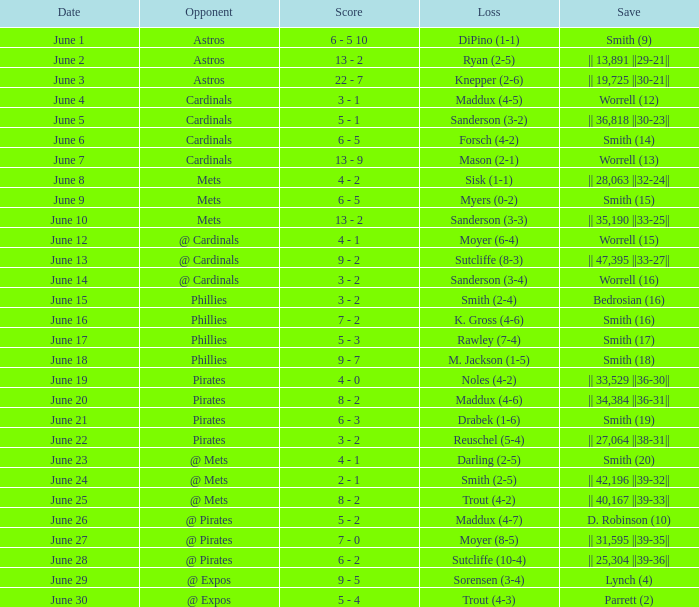Can you parse all the data within this table? {'header': ['Date', 'Opponent', 'Score', 'Loss', 'Save'], 'rows': [['June 1', 'Astros', '6 - 5 10', 'DiPino (1-1)', 'Smith (9)'], ['June 2', 'Astros', '13 - 2', 'Ryan (2-5)', '|| 13,891 ||29-21||'], ['June 3', 'Astros', '22 - 7', 'Knepper (2-6)', '|| 19,725 ||30-21||'], ['June 4', 'Cardinals', '3 - 1', 'Maddux (4-5)', 'Worrell (12)'], ['June 5', 'Cardinals', '5 - 1', 'Sanderson (3-2)', '|| 36,818 ||30-23||'], ['June 6', 'Cardinals', '6 - 5', 'Forsch (4-2)', 'Smith (14)'], ['June 7', 'Cardinals', '13 - 9', 'Mason (2-1)', 'Worrell (13)'], ['June 8', 'Mets', '4 - 2', 'Sisk (1-1)', '|| 28,063 ||32-24||'], ['June 9', 'Mets', '6 - 5', 'Myers (0-2)', 'Smith (15)'], ['June 10', 'Mets', '13 - 2', 'Sanderson (3-3)', '|| 35,190 ||33-25||'], ['June 12', '@ Cardinals', '4 - 1', 'Moyer (6-4)', 'Worrell (15)'], ['June 13', '@ Cardinals', '9 - 2', 'Sutcliffe (8-3)', '|| 47,395 ||33-27||'], ['June 14', '@ Cardinals', '3 - 2', 'Sanderson (3-4)', 'Worrell (16)'], ['June 15', 'Phillies', '3 - 2', 'Smith (2-4)', 'Bedrosian (16)'], ['June 16', 'Phillies', '7 - 2', 'K. Gross (4-6)', 'Smith (16)'], ['June 17', 'Phillies', '5 - 3', 'Rawley (7-4)', 'Smith (17)'], ['June 18', 'Phillies', '9 - 7', 'M. Jackson (1-5)', 'Smith (18)'], ['June 19', 'Pirates', '4 - 0', 'Noles (4-2)', '|| 33,529 ||36-30||'], ['June 20', 'Pirates', '8 - 2', 'Maddux (4-6)', '|| 34,384 ||36-31||'], ['June 21', 'Pirates', '6 - 3', 'Drabek (1-6)', 'Smith (19)'], ['June 22', 'Pirates', '3 - 2', 'Reuschel (5-4)', '|| 27,064 ||38-31||'], ['June 23', '@ Mets', '4 - 1', 'Darling (2-5)', 'Smith (20)'], ['June 24', '@ Mets', '2 - 1', 'Smith (2-5)', '|| 42,196 ||39-32||'], ['June 25', '@ Mets', '8 - 2', 'Trout (4-2)', '|| 40,167 ||39-33||'], ['June 26', '@ Pirates', '5 - 2', 'Maddux (4-7)', 'D. Robinson (10)'], ['June 27', '@ Pirates', '7 - 0', 'Moyer (8-5)', '|| 31,595 ||39-35||'], ['June 28', '@ Pirates', '6 - 2', 'Sutcliffe (10-4)', '|| 25,304 ||39-36||'], ['June 29', '@ Expos', '9 - 5', 'Sorensen (3-4)', 'Lynch (4)'], ['June 30', '@ Expos', '5 - 4', 'Trout (4-3)', 'Parrett (2)']]} What is the setback for the game versus @ expos, with a save of parrett (2)? Trout (4-3). 